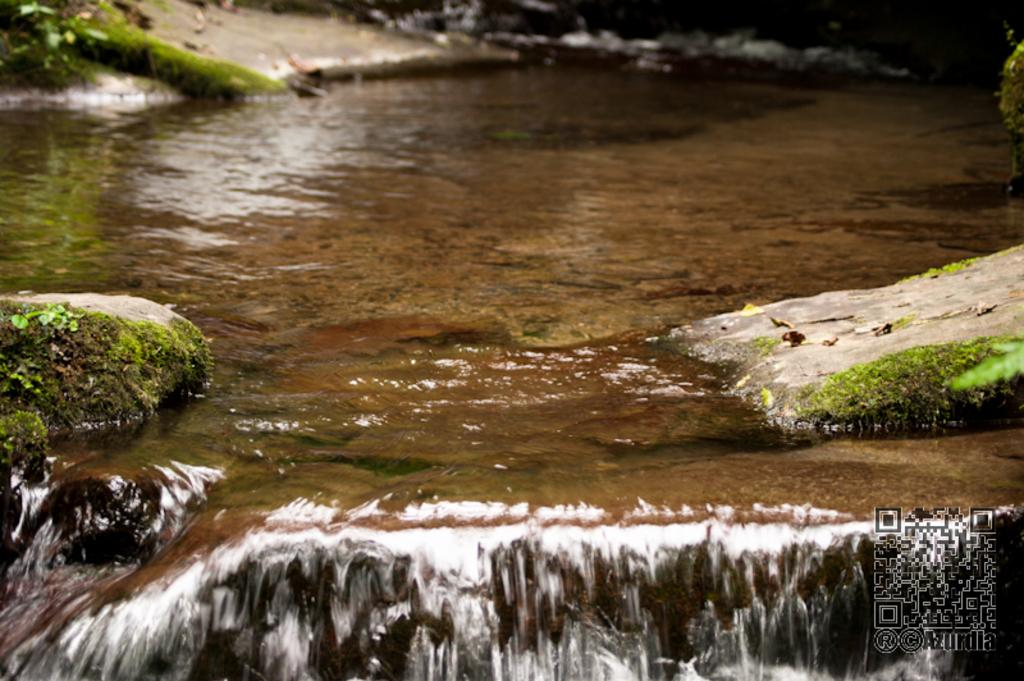What type of water feature is present in the image? There is a canal in the image. What additional feature can be found in the bottom right corner of the image? There is a QR code in the bottom right of the image. Can you describe the rocks in the image? There are rocks on both the left and right sides of the image. Where is the toothbrush located in the image? There is no toothbrush present in the image. What type of furniture can be seen in the image? There is no furniture present in the image. 